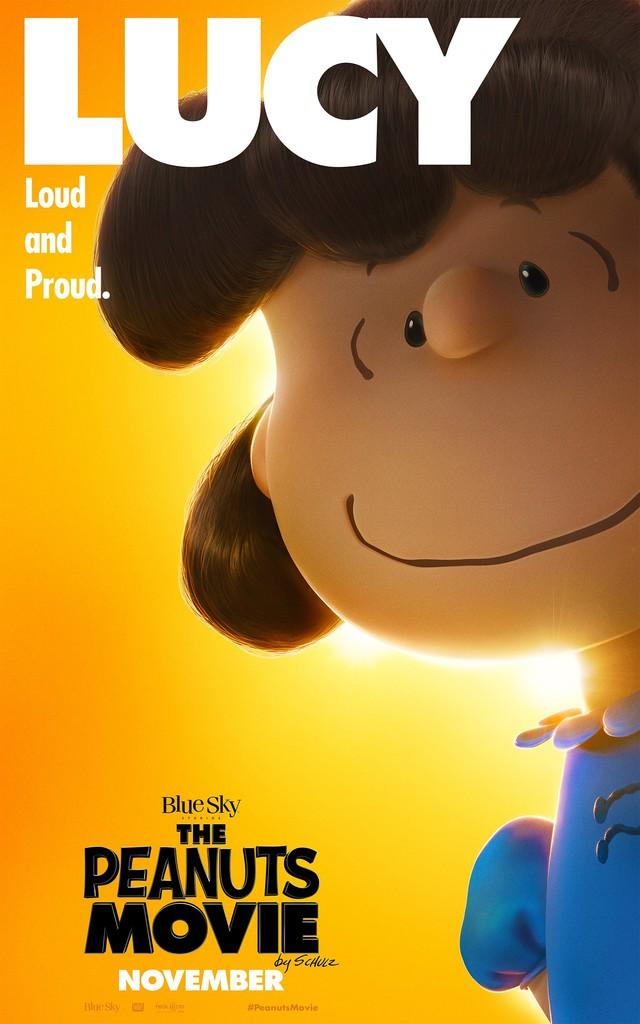What is featured in the image? There is a poster in the image. What type of image is on the poster? The poster contains a cartoon image. Is there any text on the poster? Yes, there is text on the poster. How many brothers are depicted in the cartoon image on the poster? There is no information about any brothers in the image, as it only contains a cartoon image and text on a poster. 